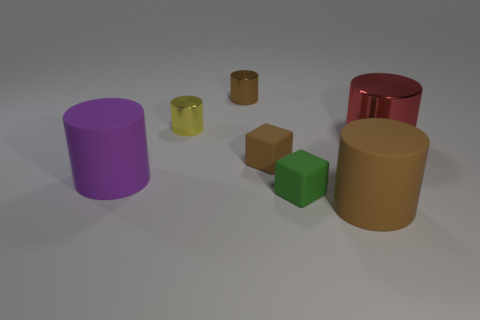Subtract all brown matte cylinders. How many cylinders are left? 4 Subtract all brown cylinders. How many cylinders are left? 3 Add 2 tiny green matte blocks. How many objects exist? 9 Subtract 2 cubes. How many cubes are left? 0 Subtract all blocks. How many objects are left? 5 Subtract all yellow cylinders. How many brown blocks are left? 1 Add 1 large purple objects. How many large purple objects exist? 2 Subtract 0 gray blocks. How many objects are left? 7 Subtract all purple cylinders. Subtract all gray spheres. How many cylinders are left? 4 Subtract all red metal cylinders. Subtract all red metal objects. How many objects are left? 5 